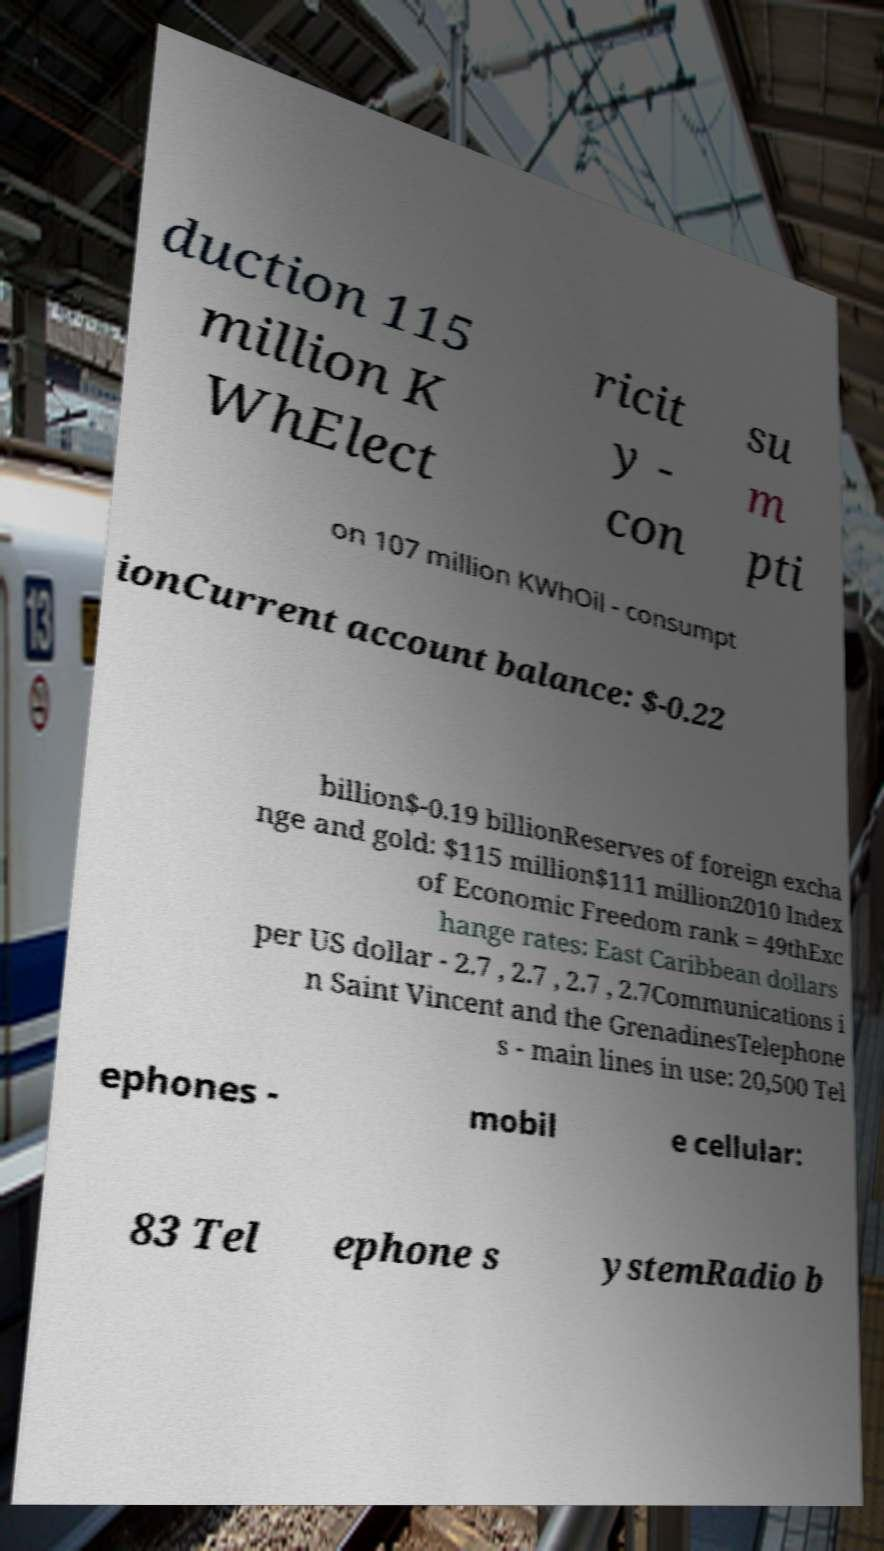Can you read and provide the text displayed in the image?This photo seems to have some interesting text. Can you extract and type it out for me? duction 115 million K WhElect ricit y - con su m pti on 107 million KWhOil - consumpt ionCurrent account balance: $-0.22 billion$-0.19 billionReserves of foreign excha nge and gold: $115 million$111 million2010 Index of Economic Freedom rank = 49thExc hange rates: East Caribbean dollars per US dollar - 2.7 , 2.7 , 2.7 , 2.7Communications i n Saint Vincent and the GrenadinesTelephone s - main lines in use: 20,500 Tel ephones - mobil e cellular: 83 Tel ephone s ystemRadio b 